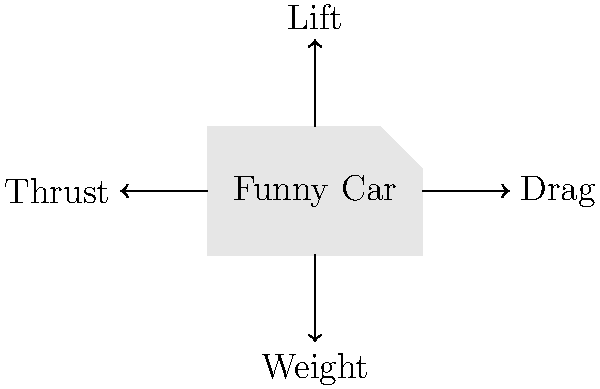In the simplified force diagram of a funny car shown above, which force is primarily responsible for keeping the car grounded and preventing it from becoming airborne during a high-speed run? To answer this question, let's analyze the forces acting on the funny car:

1. Lift: This upward force is generated by the airflow over the car's body and tends to lift the car off the ground.

2. Drag: This force opposes the car's motion through the air and doesn't directly contribute to keeping the car grounded.

3. Weight: This downward force is due to gravity and helps keep the car on the ground.

4. Thrust: This force propels the car forward but doesn't directly contribute to keeping it grounded.

5. Downforce: Although not explicitly shown in the diagram, this is a crucial force in drag racing. It's generated by aerodynamic devices like spoilers and wings, which redirect airflow to push the car downward.

The primary force responsible for keeping the car grounded during a high-speed run is downforce. While the car's weight helps, it's not sufficient at very high speeds. Downforce increases with speed, providing additional ground force when it's needed most.

In funny cars, the large rear wing and body shape are designed to generate significant downforce, often several times the car's weight at racing speeds. This downforce is critical for maintaining traction and stability, preventing the car from becoming airborne.
Answer: Downforce 